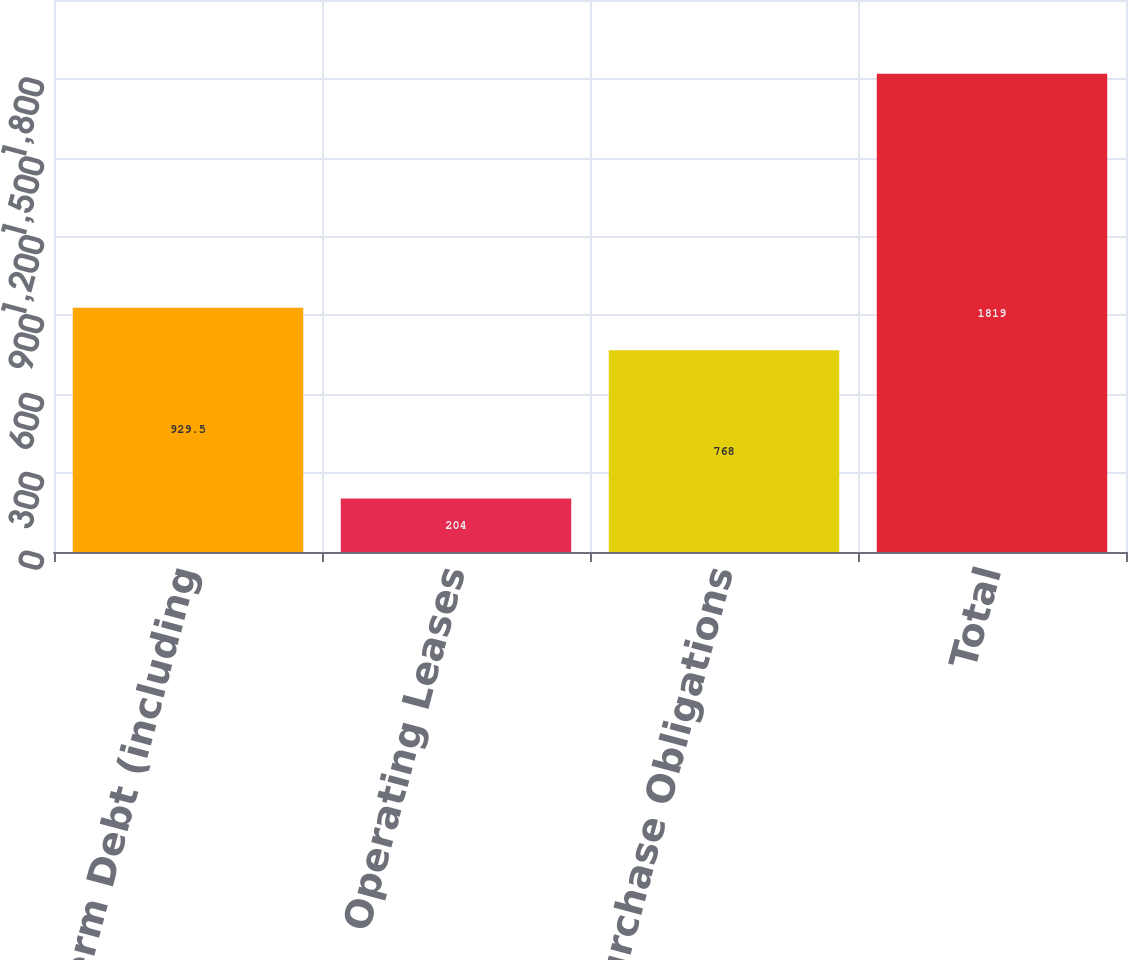<chart> <loc_0><loc_0><loc_500><loc_500><bar_chart><fcel>Long-term Debt (including<fcel>Operating Leases<fcel>Purchase Obligations<fcel>Total<nl><fcel>929.5<fcel>204<fcel>768<fcel>1819<nl></chart> 